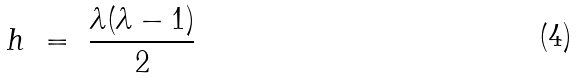<formula> <loc_0><loc_0><loc_500><loc_500>h \ = \ \frac { \lambda ( \lambda - 1 ) } { 2 } \ \</formula> 